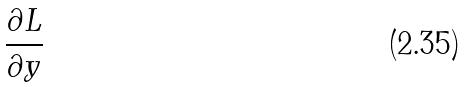Convert formula to latex. <formula><loc_0><loc_0><loc_500><loc_500>\frac { \partial L } { \partial y }</formula> 